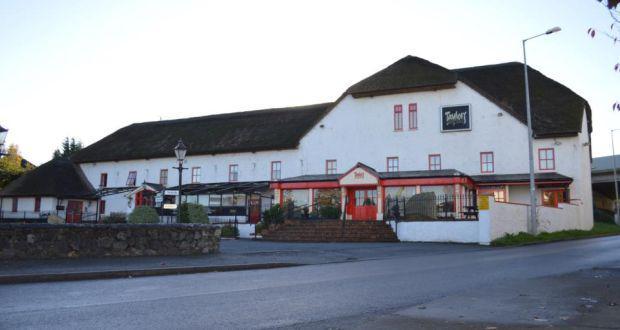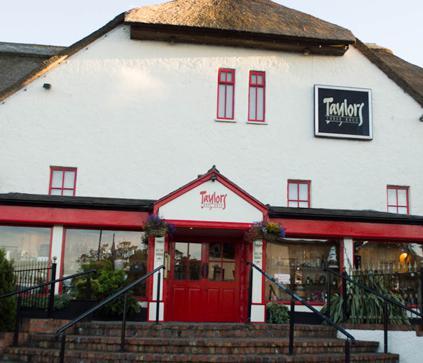The first image is the image on the left, the second image is the image on the right. Considering the images on both sides, is "In one image, at least one rightward-facing dog figure is on the rooftop of a large, pale colored building with red entrance doors." valid? Answer yes or no. No. The first image is the image on the left, the second image is the image on the right. Examine the images to the left and right. Is the description "There are wide, curved steps in front of the red door in the image on the left." accurate? Answer yes or no. Yes. 